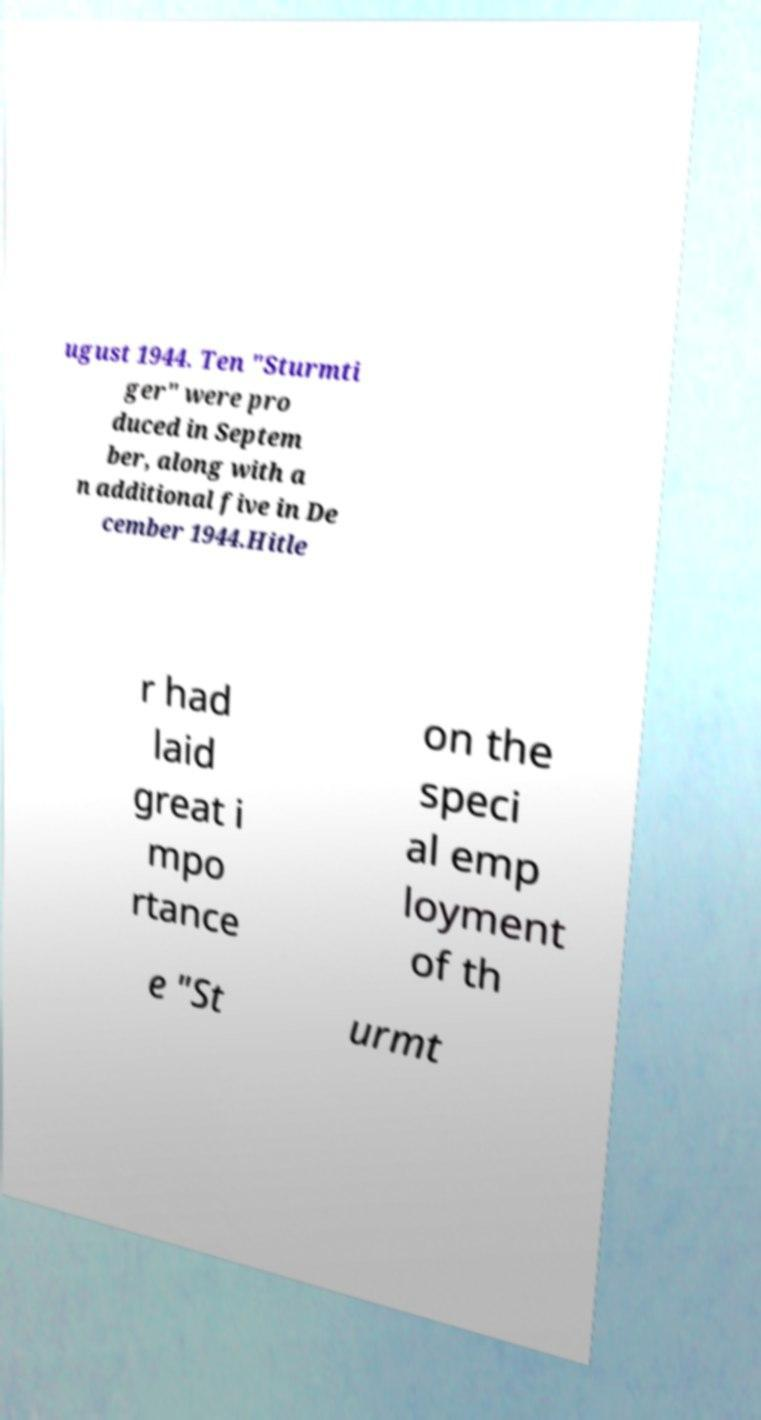Please identify and transcribe the text found in this image. ugust 1944. Ten "Sturmti ger" were pro duced in Septem ber, along with a n additional five in De cember 1944.Hitle r had laid great i mpo rtance on the speci al emp loyment of th e "St urmt 